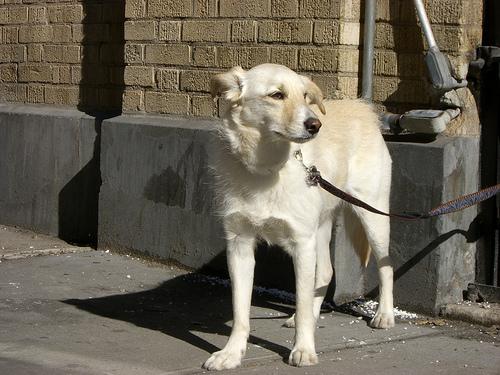Is there a human in this picture?
Keep it brief. No. What color is the dog's collar?
Keep it brief. Black. Does the dog have a owner?
Keep it brief. Yes. How many legs does the dog have?
Concise answer only. 4. 